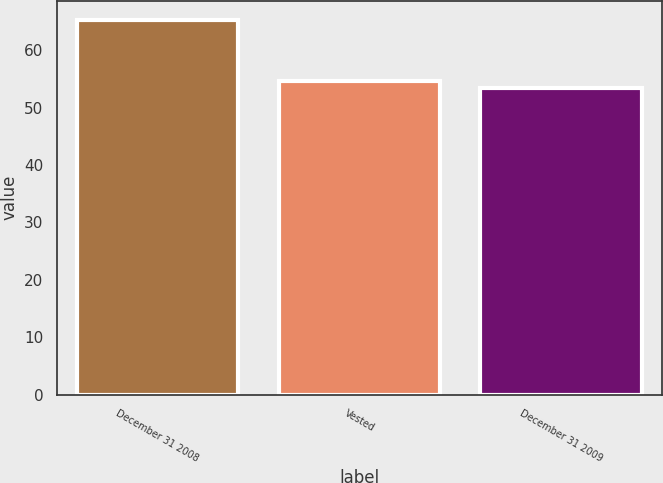Convert chart. <chart><loc_0><loc_0><loc_500><loc_500><bar_chart><fcel>December 31 2008<fcel>Vested<fcel>December 31 2009<nl><fcel>65.39<fcel>54.66<fcel>53.45<nl></chart> 